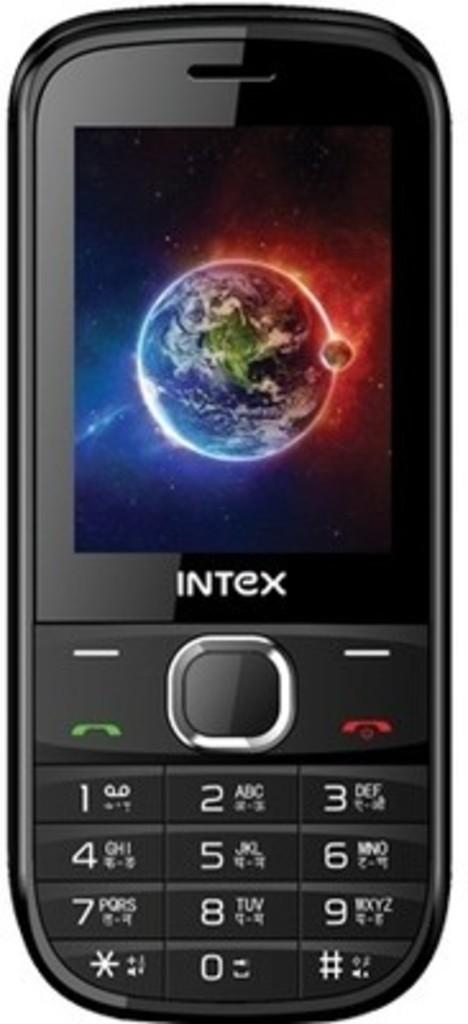Provide a one-sentence caption for the provided image. An Intex cell phone has a picture of the earth as its background. 